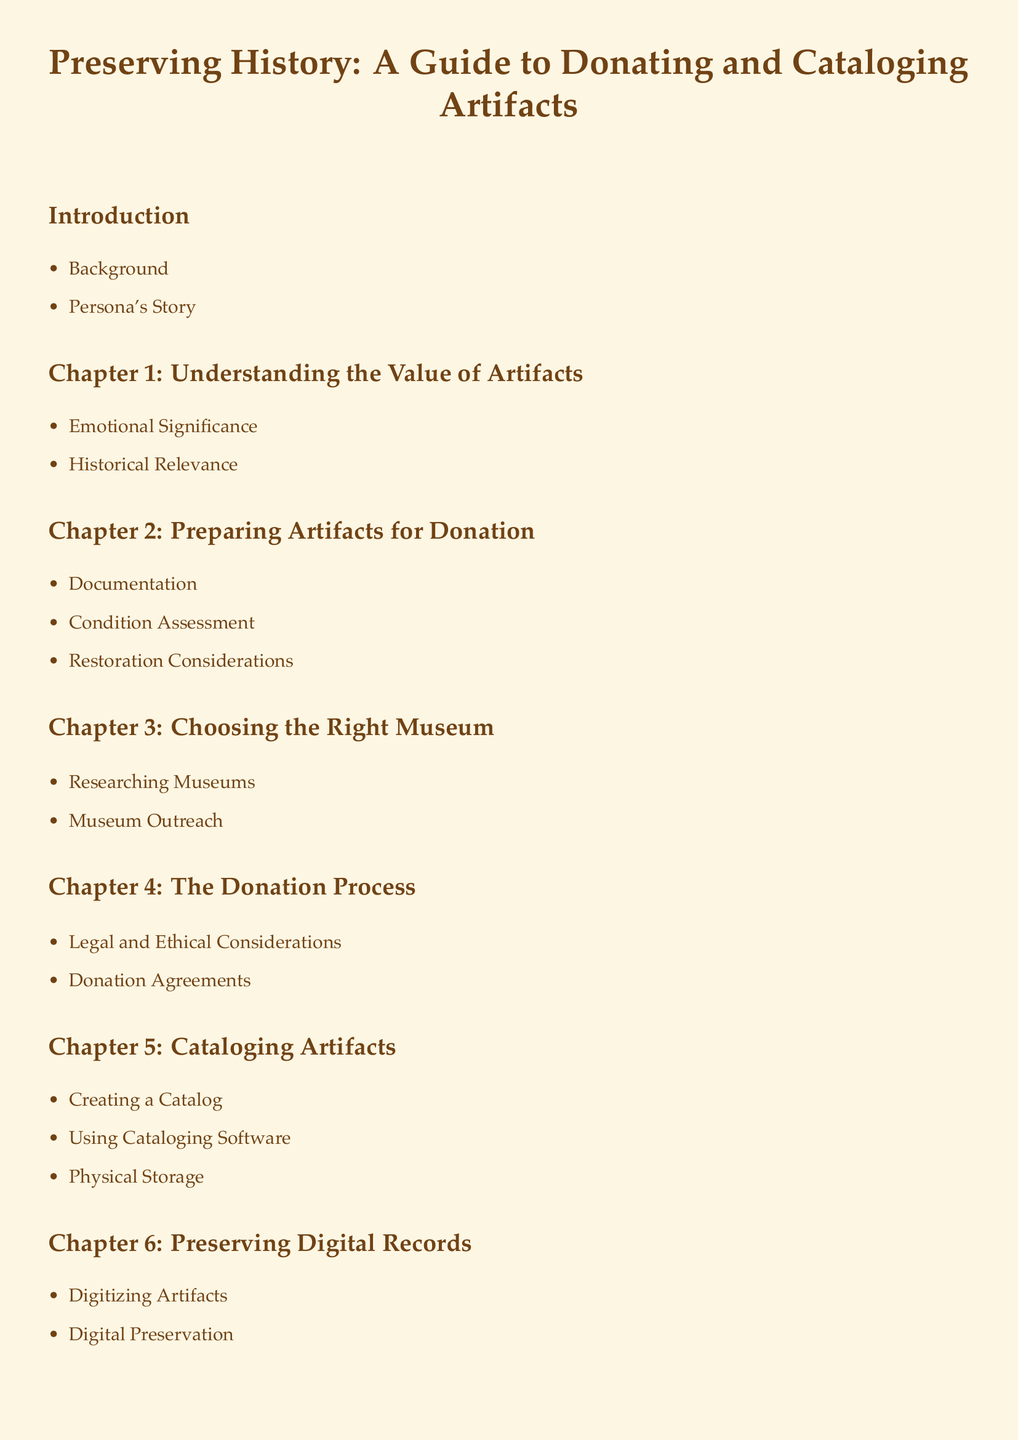what is the title of the document? The title of the document is given at the beginning of the document and is "Preserving History: A Guide to Donating and Cataloging Artifacts."
Answer: Preserving History: A Guide to Donating and Cataloging Artifacts how many chapters are there? The number of chapters can be counted from the Table of Contents, which lists six main chapters.
Answer: 6 what is the first item listed in the introduction? The first item listed in the introduction is "Background."
Answer: Background what is the focus of Chapter 2? Chapter 2 focuses on "Preparing Artifacts for Donation."
Answer: Preparing Artifacts for Donation what should you assess according to Chapter 2? Chapter 2 mentions "Condition Assessment" as part of preparing artifacts for donation.
Answer: Condition Assessment what does Chapter 6 discuss about records? Chapter 6 discusses "Preserving Digital Records."
Answer: Preserving Digital Records what is included in the appendix? The appendix includes two items: "Glossary" and "Resources."
Answer: Glossary, Resources what is the final section of the document? The final section is "Conclusion," which provides wrap-up thoughts and personal reflections.
Answer: Conclusion what document structure is being used? The document uses a structured format with sections and subsections for organization.
Answer: Structured format 